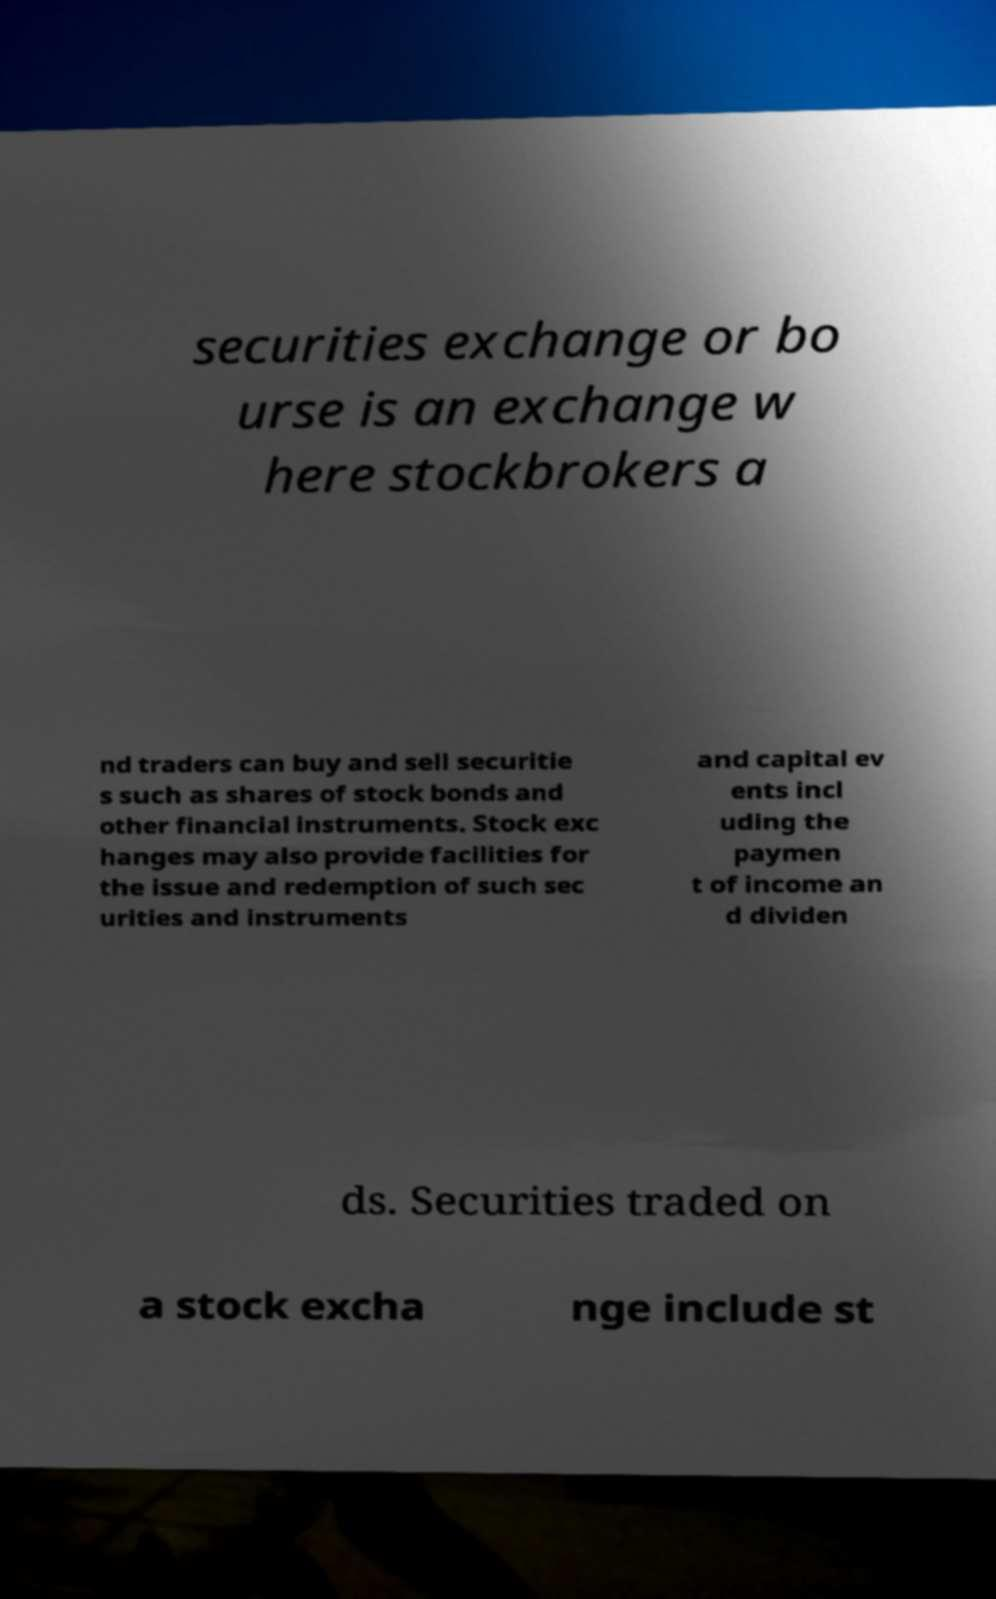Could you extract and type out the text from this image? securities exchange or bo urse is an exchange w here stockbrokers a nd traders can buy and sell securitie s such as shares of stock bonds and other financial instruments. Stock exc hanges may also provide facilities for the issue and redemption of such sec urities and instruments and capital ev ents incl uding the paymen t of income an d dividen ds. Securities traded on a stock excha nge include st 